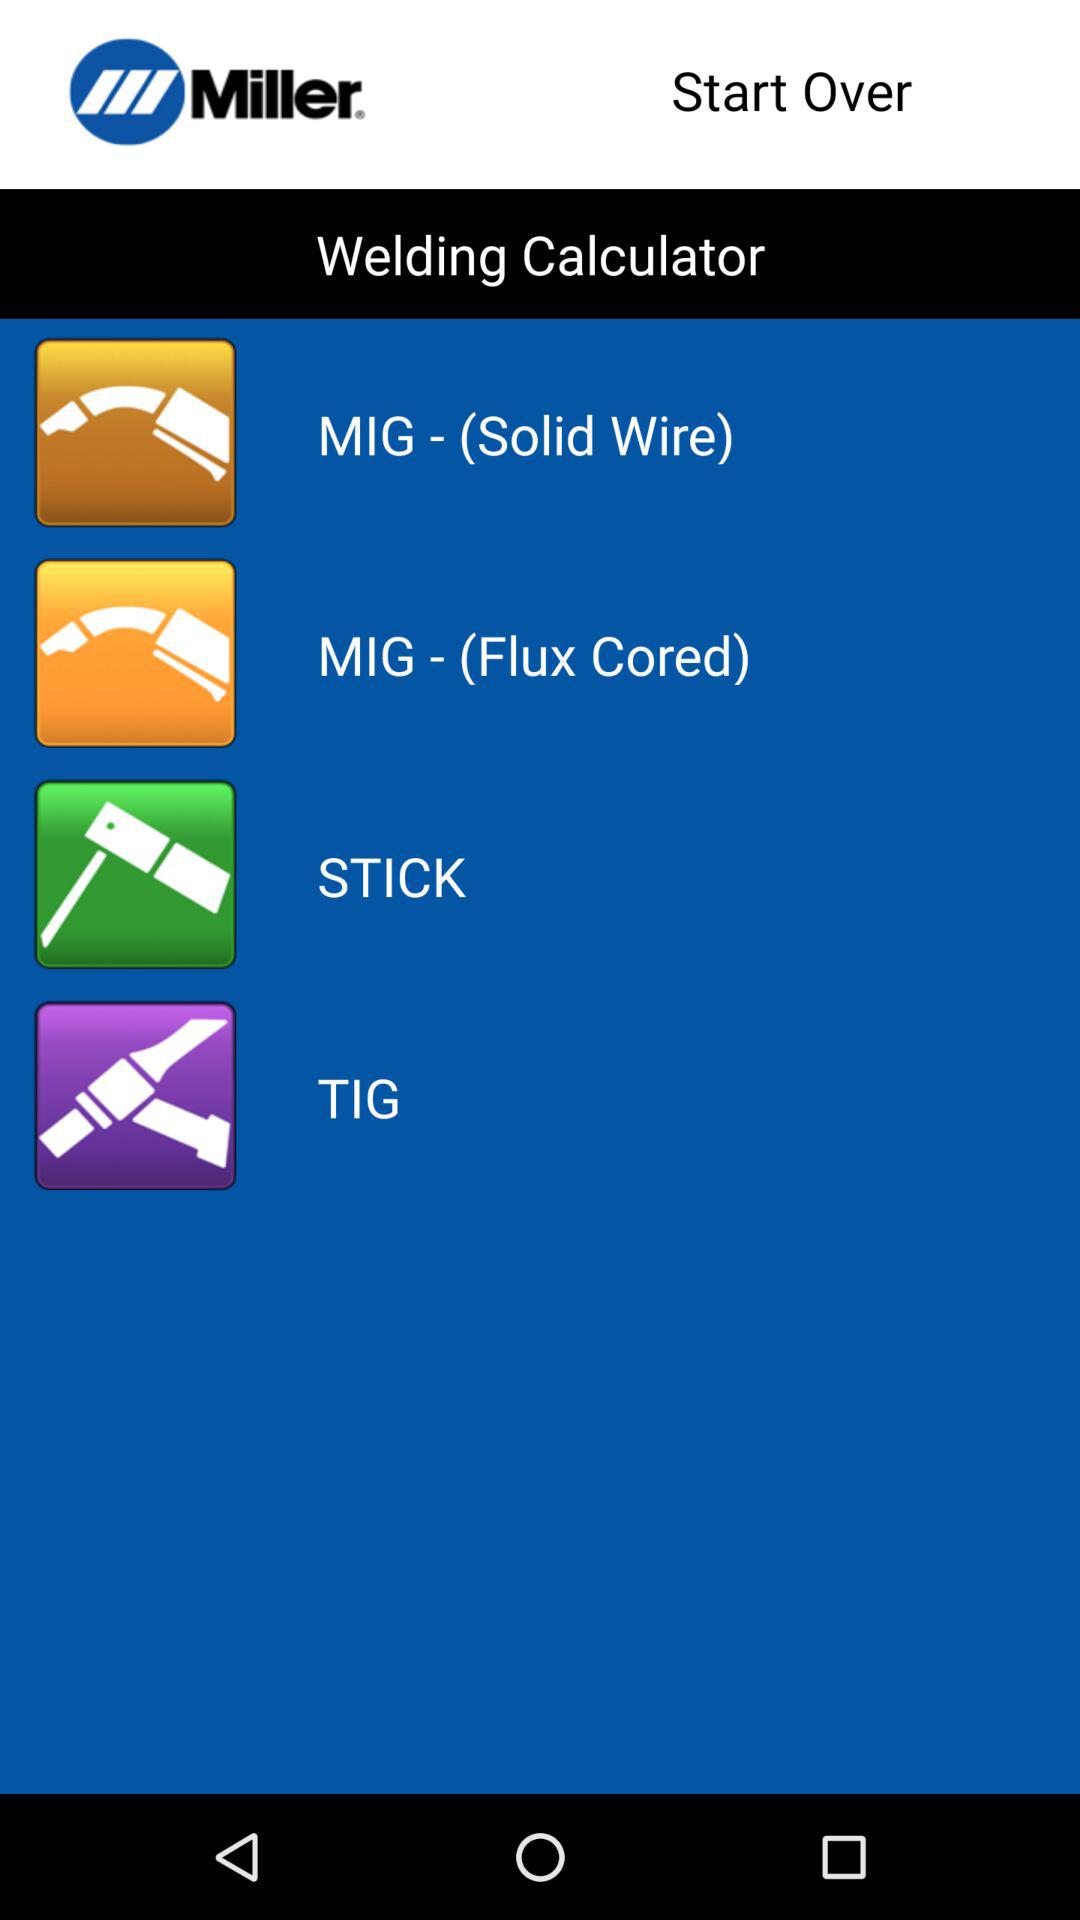How many MIG welding processes are available?
Answer the question using a single word or phrase. 2 